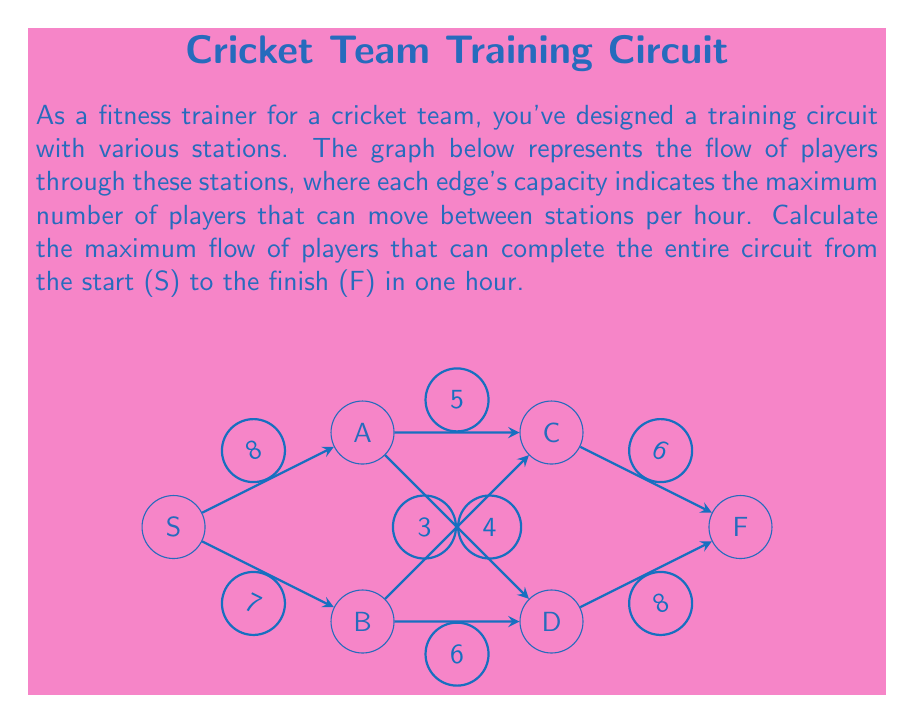Show me your answer to this math problem. To solve this maximum flow problem, we'll use the Ford-Fulkerson algorithm:

1) Initialize flow to 0 for all edges.

2) Find an augmenting path from S to F:
   Path 1: S → A → C → F (min capacity: 5)
   Update flow: 
   $$f(S,A) = 5, f(A,C) = 5, f(C,F) = 5$$
   Residual capacities:
   $$c_f(S,A) = 3, c_f(A,C) = 0, c_f(C,F) = 1$$

3) Find another augmenting path:
   Path 2: S → B → D → F (min capacity: 6)
   Update flow:
   $$f(S,B) = 6, f(B,D) = 6, f(D,F) = 6$$
   Residual capacities:
   $$c_f(S,B) = 1, c_f(B,D) = 0, c_f(D,F) = 2$$

4) Find another augmenting path:
   Path 3: S → A → D → F (min capacity: 2)
   Update flow:
   $$f(S,A) = 7, f(A,D) = 2, f(D,F) = 8$$
   Residual capacities:
   $$c_f(S,A) = 1, c_f(A,D) = 1, c_f(D,F) = 0$$

5) Find another augmenting path:
   Path 4: S → B → C → F (min capacity: 1)
   Update flow:
   $$f(S,B) = 7, f(B,C) = 1, f(C,F) = 6$$
   Residual capacities:
   $$c_f(S,B) = 0, c_f(B,C) = 3, c_f(C,F) = 0$$

6) No more augmenting paths exist. The maximum flow is the sum of flows out of S:
   $$\text{Max Flow} = f(S,A) + f(S,B) = 7 + 7 = 14$$
Answer: 14 players per hour 